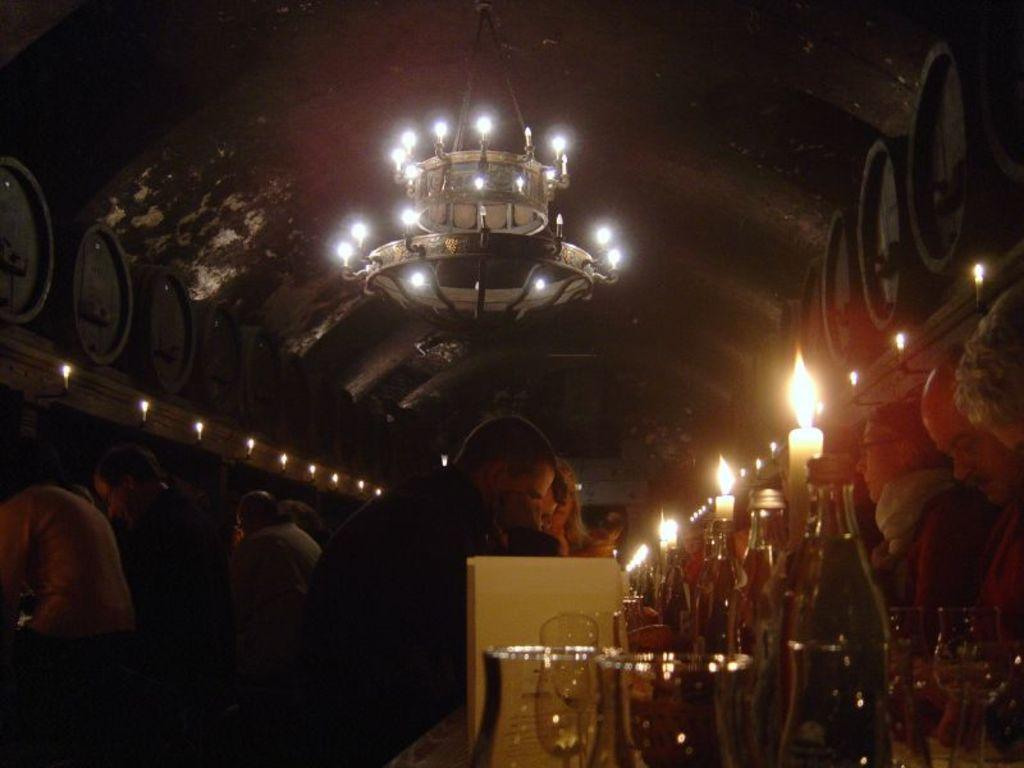What type of furniture is present in the image? There is a table in the image. What objects can be seen on the table? There are glasses, bottles, and candles on the table. What are the people in the image doing? There are people sitting on chairs in the image. What is visible above the table in the image? There is a ceiling with lights in the image. What additional objects are present in the image? There are barrels in the image. Can you see any fairies flying around the candles in the image? There are no fairies present in the image. What type of birds can be seen perched on the barrels in the image? There are no birds visible in the image; it only features a table, glasses, bottles, candles, people sitting on chairs, a ceiling with lights, and barrels. 